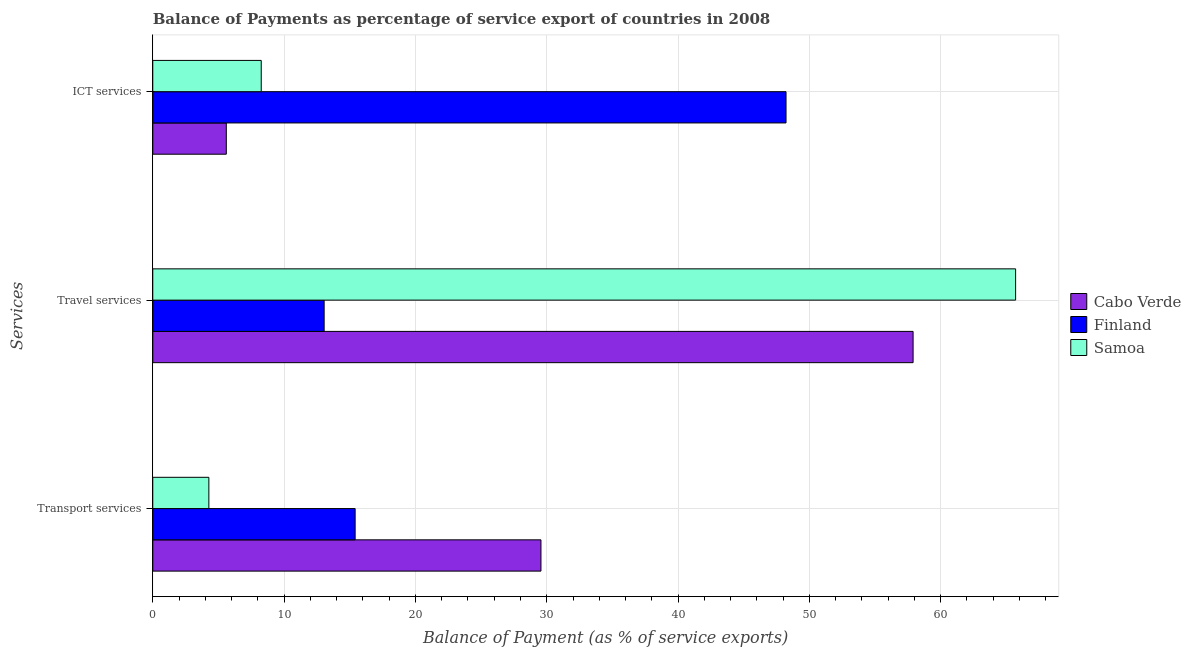How many groups of bars are there?
Your answer should be compact. 3. Are the number of bars per tick equal to the number of legend labels?
Keep it short and to the point. Yes. What is the label of the 1st group of bars from the top?
Make the answer very short. ICT services. What is the balance of payment of travel services in Cabo Verde?
Ensure brevity in your answer.  57.9. Across all countries, what is the maximum balance of payment of ict services?
Provide a short and direct response. 48.22. Across all countries, what is the minimum balance of payment of ict services?
Provide a short and direct response. 5.6. In which country was the balance of payment of transport services maximum?
Ensure brevity in your answer.  Cabo Verde. In which country was the balance of payment of transport services minimum?
Offer a very short reply. Samoa. What is the total balance of payment of ict services in the graph?
Make the answer very short. 62.08. What is the difference between the balance of payment of ict services in Samoa and that in Cabo Verde?
Your response must be concise. 2.66. What is the difference between the balance of payment of ict services in Cabo Verde and the balance of payment of travel services in Finland?
Your answer should be compact. -7.45. What is the average balance of payment of travel services per country?
Provide a succinct answer. 45.55. What is the difference between the balance of payment of travel services and balance of payment of ict services in Samoa?
Offer a terse response. 57.45. In how many countries, is the balance of payment of ict services greater than 20 %?
Ensure brevity in your answer.  1. What is the ratio of the balance of payment of travel services in Samoa to that in Cabo Verde?
Make the answer very short. 1.13. Is the balance of payment of transport services in Finland less than that in Cabo Verde?
Keep it short and to the point. Yes. What is the difference between the highest and the second highest balance of payment of ict services?
Ensure brevity in your answer.  39.96. What is the difference between the highest and the lowest balance of payment of travel services?
Make the answer very short. 52.66. In how many countries, is the balance of payment of travel services greater than the average balance of payment of travel services taken over all countries?
Provide a succinct answer. 2. Is the sum of the balance of payment of travel services in Cabo Verde and Finland greater than the maximum balance of payment of ict services across all countries?
Ensure brevity in your answer.  Yes. What does the 3rd bar from the bottom in Travel services represents?
Your answer should be very brief. Samoa. How many countries are there in the graph?
Make the answer very short. 3. What is the difference between two consecutive major ticks on the X-axis?
Ensure brevity in your answer.  10. Are the values on the major ticks of X-axis written in scientific E-notation?
Provide a succinct answer. No. Does the graph contain any zero values?
Offer a very short reply. No. Does the graph contain grids?
Provide a succinct answer. Yes. How many legend labels are there?
Your response must be concise. 3. What is the title of the graph?
Ensure brevity in your answer.  Balance of Payments as percentage of service export of countries in 2008. Does "Latin America(all income levels)" appear as one of the legend labels in the graph?
Your answer should be very brief. No. What is the label or title of the X-axis?
Provide a succinct answer. Balance of Payment (as % of service exports). What is the label or title of the Y-axis?
Your answer should be compact. Services. What is the Balance of Payment (as % of service exports) of Cabo Verde in Transport services?
Provide a short and direct response. 29.56. What is the Balance of Payment (as % of service exports) in Finland in Transport services?
Provide a short and direct response. 15.41. What is the Balance of Payment (as % of service exports) of Samoa in Transport services?
Make the answer very short. 4.27. What is the Balance of Payment (as % of service exports) in Cabo Verde in Travel services?
Offer a very short reply. 57.9. What is the Balance of Payment (as % of service exports) of Finland in Travel services?
Offer a very short reply. 13.05. What is the Balance of Payment (as % of service exports) of Samoa in Travel services?
Your response must be concise. 65.71. What is the Balance of Payment (as % of service exports) in Cabo Verde in ICT services?
Your answer should be compact. 5.6. What is the Balance of Payment (as % of service exports) of Finland in ICT services?
Your answer should be very brief. 48.22. What is the Balance of Payment (as % of service exports) of Samoa in ICT services?
Provide a succinct answer. 8.26. Across all Services, what is the maximum Balance of Payment (as % of service exports) in Cabo Verde?
Offer a terse response. 57.9. Across all Services, what is the maximum Balance of Payment (as % of service exports) in Finland?
Keep it short and to the point. 48.22. Across all Services, what is the maximum Balance of Payment (as % of service exports) in Samoa?
Provide a short and direct response. 65.71. Across all Services, what is the minimum Balance of Payment (as % of service exports) of Cabo Verde?
Keep it short and to the point. 5.6. Across all Services, what is the minimum Balance of Payment (as % of service exports) of Finland?
Your answer should be very brief. 13.05. Across all Services, what is the minimum Balance of Payment (as % of service exports) in Samoa?
Your response must be concise. 4.27. What is the total Balance of Payment (as % of service exports) in Cabo Verde in the graph?
Offer a terse response. 93.06. What is the total Balance of Payment (as % of service exports) in Finland in the graph?
Ensure brevity in your answer.  76.68. What is the total Balance of Payment (as % of service exports) in Samoa in the graph?
Give a very brief answer. 78.24. What is the difference between the Balance of Payment (as % of service exports) of Cabo Verde in Transport services and that in Travel services?
Your response must be concise. -28.34. What is the difference between the Balance of Payment (as % of service exports) of Finland in Transport services and that in Travel services?
Keep it short and to the point. 2.36. What is the difference between the Balance of Payment (as % of service exports) of Samoa in Transport services and that in Travel services?
Your answer should be very brief. -61.43. What is the difference between the Balance of Payment (as % of service exports) of Cabo Verde in Transport services and that in ICT services?
Provide a succinct answer. 23.96. What is the difference between the Balance of Payment (as % of service exports) of Finland in Transport services and that in ICT services?
Ensure brevity in your answer.  -32.81. What is the difference between the Balance of Payment (as % of service exports) of Samoa in Transport services and that in ICT services?
Offer a very short reply. -3.99. What is the difference between the Balance of Payment (as % of service exports) in Cabo Verde in Travel services and that in ICT services?
Keep it short and to the point. 52.3. What is the difference between the Balance of Payment (as % of service exports) of Finland in Travel services and that in ICT services?
Ensure brevity in your answer.  -35.17. What is the difference between the Balance of Payment (as % of service exports) in Samoa in Travel services and that in ICT services?
Give a very brief answer. 57.45. What is the difference between the Balance of Payment (as % of service exports) in Cabo Verde in Transport services and the Balance of Payment (as % of service exports) in Finland in Travel services?
Your answer should be very brief. 16.51. What is the difference between the Balance of Payment (as % of service exports) in Cabo Verde in Transport services and the Balance of Payment (as % of service exports) in Samoa in Travel services?
Offer a terse response. -36.15. What is the difference between the Balance of Payment (as % of service exports) of Finland in Transport services and the Balance of Payment (as % of service exports) of Samoa in Travel services?
Provide a succinct answer. -50.3. What is the difference between the Balance of Payment (as % of service exports) of Cabo Verde in Transport services and the Balance of Payment (as % of service exports) of Finland in ICT services?
Make the answer very short. -18.66. What is the difference between the Balance of Payment (as % of service exports) in Cabo Verde in Transport services and the Balance of Payment (as % of service exports) in Samoa in ICT services?
Provide a short and direct response. 21.3. What is the difference between the Balance of Payment (as % of service exports) of Finland in Transport services and the Balance of Payment (as % of service exports) of Samoa in ICT services?
Your response must be concise. 7.15. What is the difference between the Balance of Payment (as % of service exports) in Cabo Verde in Travel services and the Balance of Payment (as % of service exports) in Finland in ICT services?
Keep it short and to the point. 9.68. What is the difference between the Balance of Payment (as % of service exports) in Cabo Verde in Travel services and the Balance of Payment (as % of service exports) in Samoa in ICT services?
Your answer should be compact. 49.64. What is the difference between the Balance of Payment (as % of service exports) of Finland in Travel services and the Balance of Payment (as % of service exports) of Samoa in ICT services?
Make the answer very short. 4.79. What is the average Balance of Payment (as % of service exports) in Cabo Verde per Services?
Offer a very short reply. 31.02. What is the average Balance of Payment (as % of service exports) in Finland per Services?
Make the answer very short. 25.56. What is the average Balance of Payment (as % of service exports) in Samoa per Services?
Your answer should be very brief. 26.08. What is the difference between the Balance of Payment (as % of service exports) of Cabo Verde and Balance of Payment (as % of service exports) of Finland in Transport services?
Keep it short and to the point. 14.15. What is the difference between the Balance of Payment (as % of service exports) in Cabo Verde and Balance of Payment (as % of service exports) in Samoa in Transport services?
Offer a terse response. 25.29. What is the difference between the Balance of Payment (as % of service exports) in Finland and Balance of Payment (as % of service exports) in Samoa in Transport services?
Your answer should be compact. 11.14. What is the difference between the Balance of Payment (as % of service exports) in Cabo Verde and Balance of Payment (as % of service exports) in Finland in Travel services?
Give a very brief answer. 44.85. What is the difference between the Balance of Payment (as % of service exports) of Cabo Verde and Balance of Payment (as % of service exports) of Samoa in Travel services?
Give a very brief answer. -7.81. What is the difference between the Balance of Payment (as % of service exports) in Finland and Balance of Payment (as % of service exports) in Samoa in Travel services?
Provide a short and direct response. -52.66. What is the difference between the Balance of Payment (as % of service exports) of Cabo Verde and Balance of Payment (as % of service exports) of Finland in ICT services?
Your response must be concise. -42.62. What is the difference between the Balance of Payment (as % of service exports) of Cabo Verde and Balance of Payment (as % of service exports) of Samoa in ICT services?
Give a very brief answer. -2.66. What is the difference between the Balance of Payment (as % of service exports) in Finland and Balance of Payment (as % of service exports) in Samoa in ICT services?
Give a very brief answer. 39.96. What is the ratio of the Balance of Payment (as % of service exports) of Cabo Verde in Transport services to that in Travel services?
Your response must be concise. 0.51. What is the ratio of the Balance of Payment (as % of service exports) of Finland in Transport services to that in Travel services?
Provide a succinct answer. 1.18. What is the ratio of the Balance of Payment (as % of service exports) of Samoa in Transport services to that in Travel services?
Provide a succinct answer. 0.07. What is the ratio of the Balance of Payment (as % of service exports) of Cabo Verde in Transport services to that in ICT services?
Provide a succinct answer. 5.28. What is the ratio of the Balance of Payment (as % of service exports) in Finland in Transport services to that in ICT services?
Make the answer very short. 0.32. What is the ratio of the Balance of Payment (as % of service exports) of Samoa in Transport services to that in ICT services?
Keep it short and to the point. 0.52. What is the ratio of the Balance of Payment (as % of service exports) in Cabo Verde in Travel services to that in ICT services?
Ensure brevity in your answer.  10.34. What is the ratio of the Balance of Payment (as % of service exports) in Finland in Travel services to that in ICT services?
Keep it short and to the point. 0.27. What is the ratio of the Balance of Payment (as % of service exports) of Samoa in Travel services to that in ICT services?
Your answer should be very brief. 7.96. What is the difference between the highest and the second highest Balance of Payment (as % of service exports) in Cabo Verde?
Give a very brief answer. 28.34. What is the difference between the highest and the second highest Balance of Payment (as % of service exports) in Finland?
Make the answer very short. 32.81. What is the difference between the highest and the second highest Balance of Payment (as % of service exports) of Samoa?
Provide a short and direct response. 57.45. What is the difference between the highest and the lowest Balance of Payment (as % of service exports) in Cabo Verde?
Make the answer very short. 52.3. What is the difference between the highest and the lowest Balance of Payment (as % of service exports) in Finland?
Provide a succinct answer. 35.17. What is the difference between the highest and the lowest Balance of Payment (as % of service exports) of Samoa?
Give a very brief answer. 61.43. 